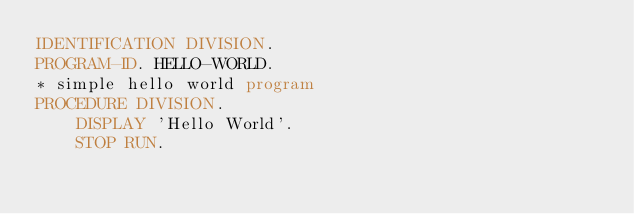Convert code to text. <code><loc_0><loc_0><loc_500><loc_500><_COBOL_>IDENTIFICATION DIVISION.
PROGRAM-ID. HELLO-WORLD.
* simple hello world program
PROCEDURE DIVISION.
    DISPLAY 'Hello World'.
    STOP RUN.
</code> 